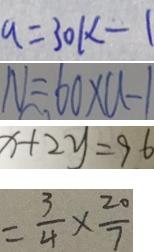<formula> <loc_0><loc_0><loc_500><loc_500>q = 3 0 k - 1 
 N = 6 0 \times a - 1 
 x + 2 y = 9 6 
 = \frac { 3 } { 4 } \times \frac { 2 0 } { 7 }</formula> 